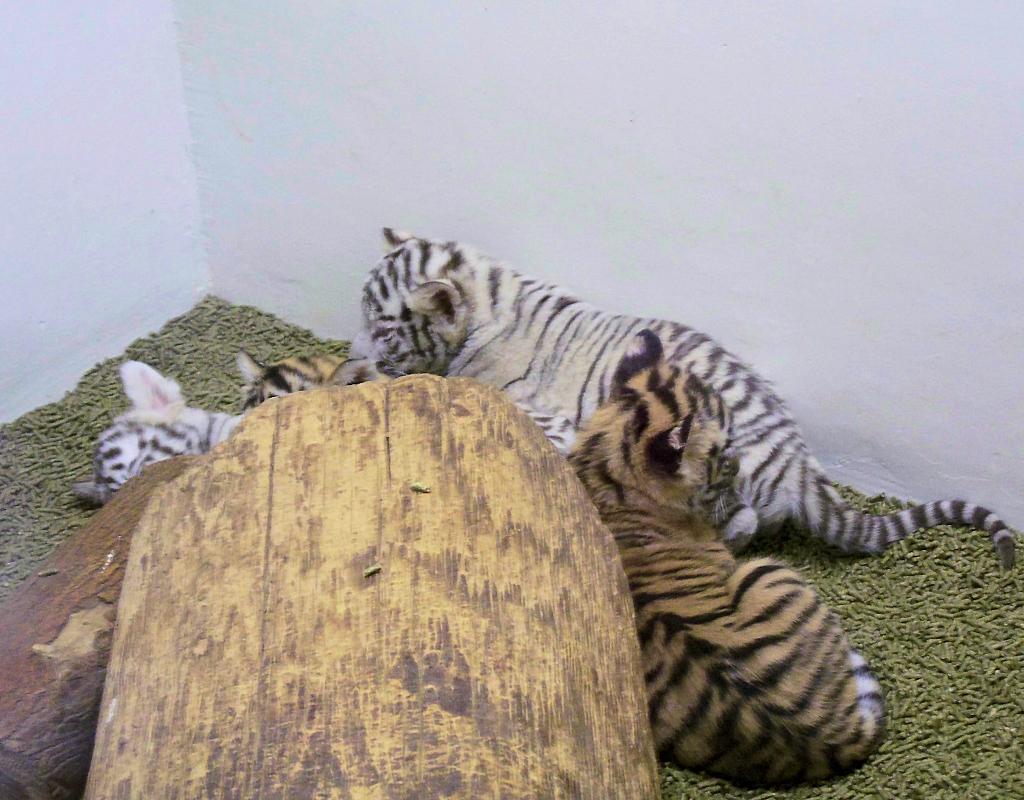Can you describe this image briefly? In this picture, we see the wooden blocks. At the bottom, it is green in color and it might be an artificial grass. In the middle, we see the cubs. In the background, we see a wall in white color. 